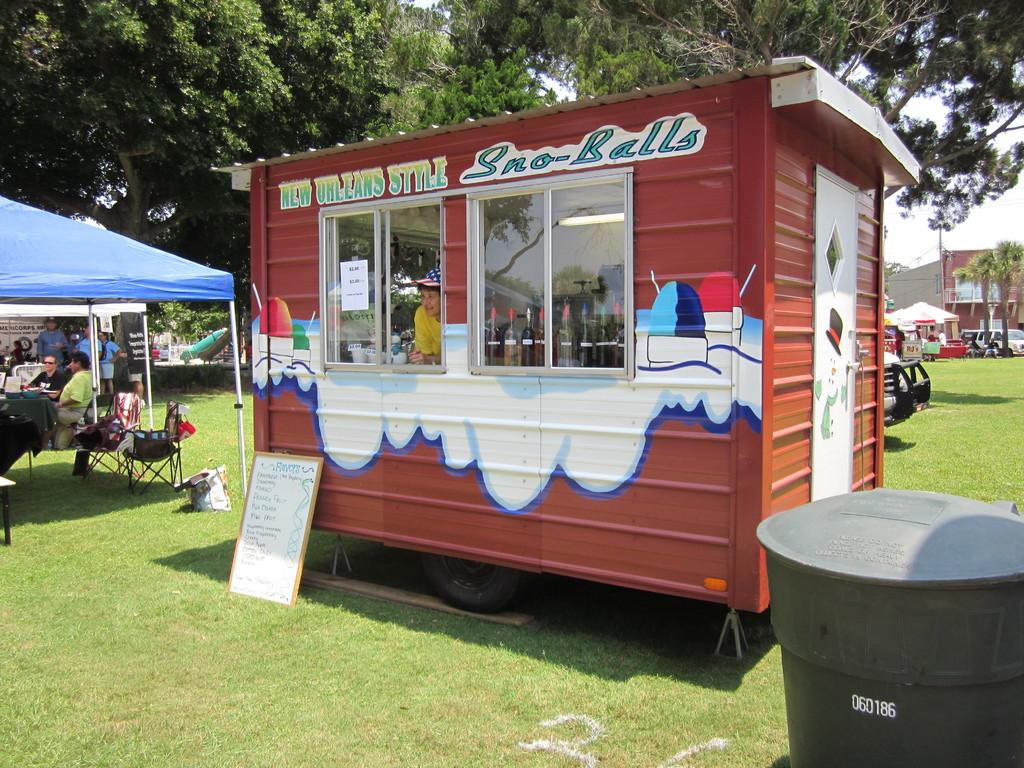What is the shack selling?
Make the answer very short. Sno-balls. What style of sno-balls?
Your answer should be compact. New orleans. 